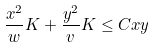<formula> <loc_0><loc_0><loc_500><loc_500>\frac { x ^ { 2 } } { w } K + \frac { y ^ { 2 } } { v } K \leq C x y</formula> 